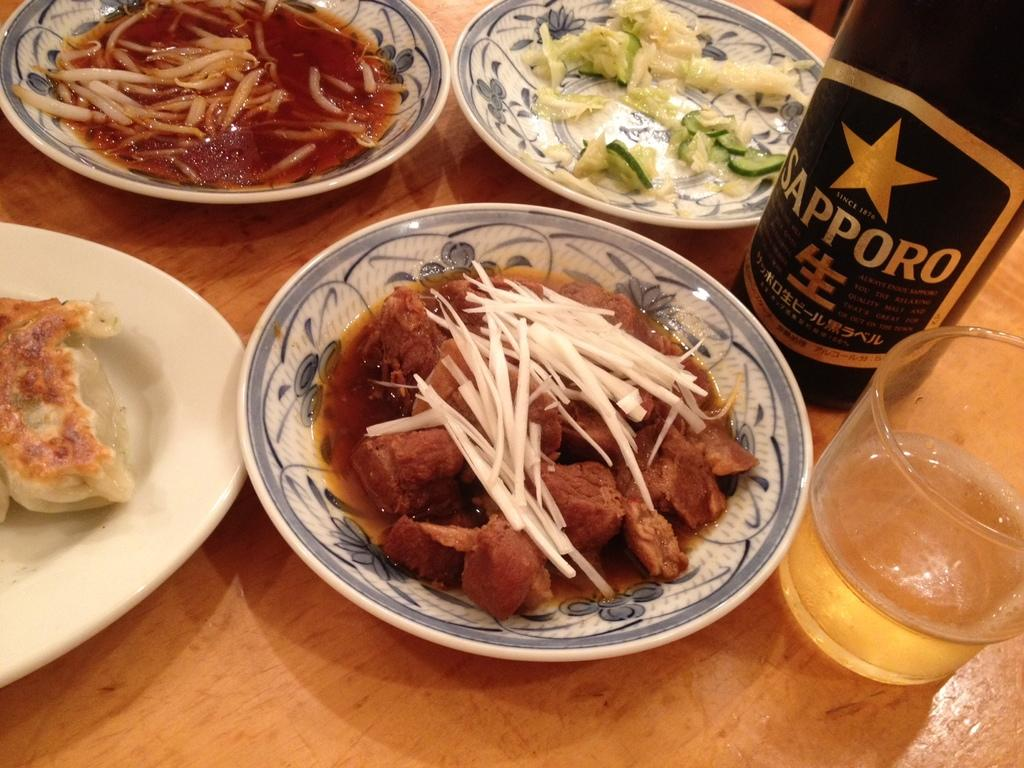What type of table is in the image? There is a wooden table in the image. What objects are on the table? There are plates, bottles, a glass, and food on the table. Can you describe the food on the table? The provided facts do not specify the type of food on the table. Where is the cannon located in the image? There is no cannon present in the image. What is the cent of the table in the image? The provided facts do not mention a cent or any measurement related to the table. 